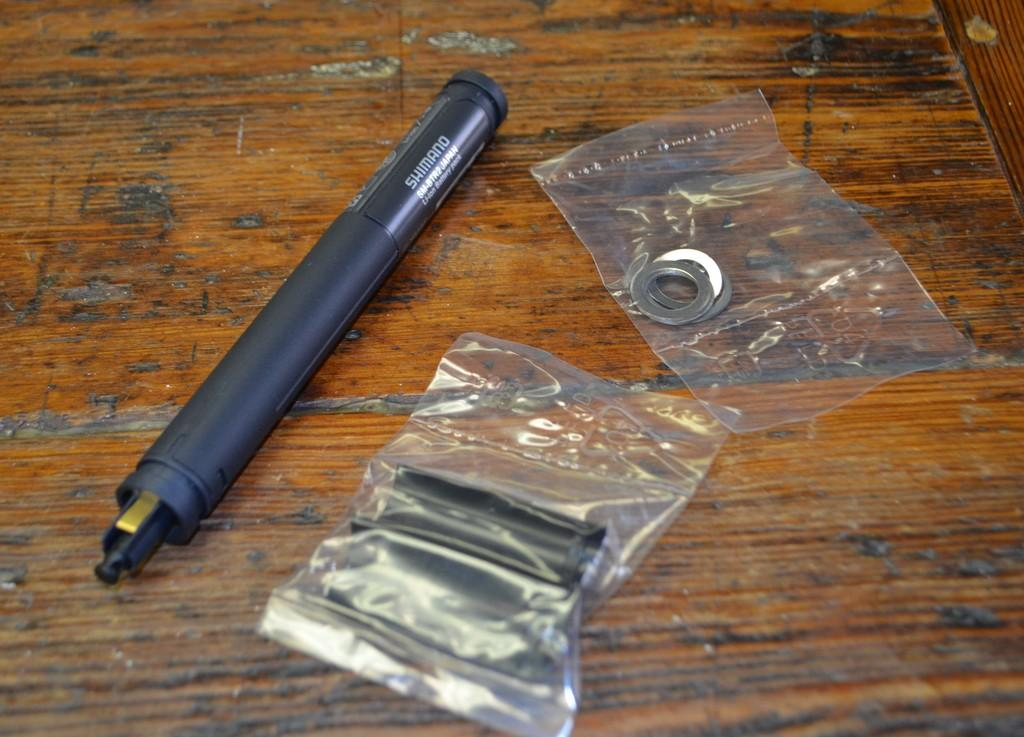What is the main object visible in the image? There is a pen in the image. What else can be seen in the image besides the pen? There are two cover packets in the image. What type of objects are inside the cover packets? The cover packets contain metal objects. Where are the objects placed in the image? The objects are placed on a table. How many pizzas are being served on the table in the image? There are no pizzas present in the image; the objects on the table are a pen and two cover packets containing metal objects. What type of cracker is being used to write on the table in the image? There is no cracker present in the image, and the pen is not being used to write on the table. 